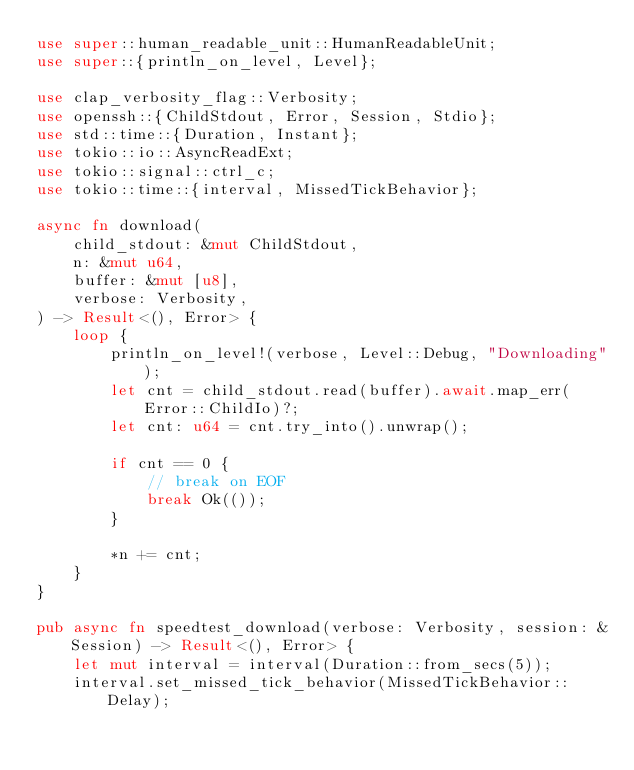Convert code to text. <code><loc_0><loc_0><loc_500><loc_500><_Rust_>use super::human_readable_unit::HumanReadableUnit;
use super::{println_on_level, Level};

use clap_verbosity_flag::Verbosity;
use openssh::{ChildStdout, Error, Session, Stdio};
use std::time::{Duration, Instant};
use tokio::io::AsyncReadExt;
use tokio::signal::ctrl_c;
use tokio::time::{interval, MissedTickBehavior};

async fn download(
    child_stdout: &mut ChildStdout,
    n: &mut u64,
    buffer: &mut [u8],
    verbose: Verbosity,
) -> Result<(), Error> {
    loop {
        println_on_level!(verbose, Level::Debug, "Downloading");
        let cnt = child_stdout.read(buffer).await.map_err(Error::ChildIo)?;
        let cnt: u64 = cnt.try_into().unwrap();

        if cnt == 0 {
            // break on EOF
            break Ok(());
        }

        *n += cnt;
    }
}

pub async fn speedtest_download(verbose: Verbosity, session: &Session) -> Result<(), Error> {
    let mut interval = interval(Duration::from_secs(5));
    interval.set_missed_tick_behavior(MissedTickBehavior::Delay);
</code> 